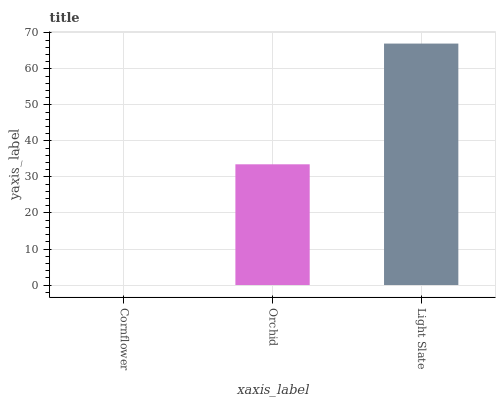Is Cornflower the minimum?
Answer yes or no. Yes. Is Light Slate the maximum?
Answer yes or no. Yes. Is Orchid the minimum?
Answer yes or no. No. Is Orchid the maximum?
Answer yes or no. No. Is Orchid greater than Cornflower?
Answer yes or no. Yes. Is Cornflower less than Orchid?
Answer yes or no. Yes. Is Cornflower greater than Orchid?
Answer yes or no. No. Is Orchid less than Cornflower?
Answer yes or no. No. Is Orchid the high median?
Answer yes or no. Yes. Is Orchid the low median?
Answer yes or no. Yes. Is Light Slate the high median?
Answer yes or no. No. Is Cornflower the low median?
Answer yes or no. No. 